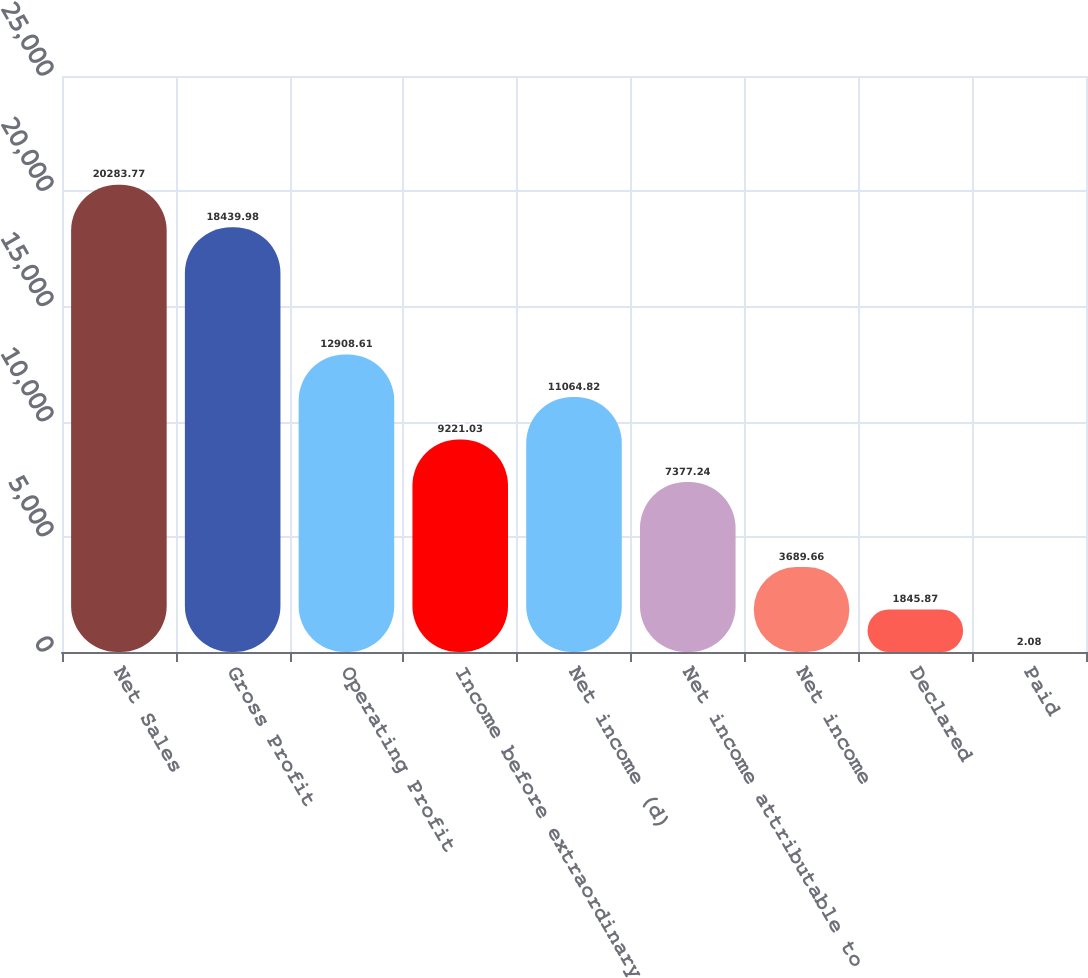Convert chart. <chart><loc_0><loc_0><loc_500><loc_500><bar_chart><fcel>Net Sales<fcel>Gross Profit<fcel>Operating Profit<fcel>Income before extraordinary<fcel>Net income (d)<fcel>Net income attributable to<fcel>Net income<fcel>Declared<fcel>Paid<nl><fcel>20283.8<fcel>18440<fcel>12908.6<fcel>9221.03<fcel>11064.8<fcel>7377.24<fcel>3689.66<fcel>1845.87<fcel>2.08<nl></chart> 